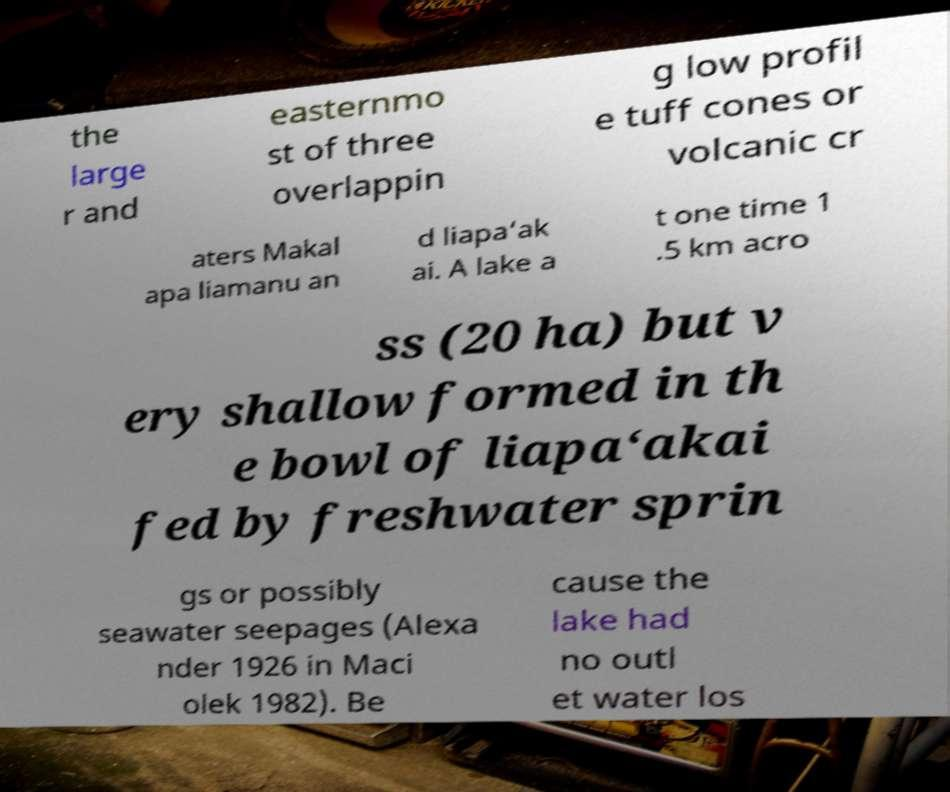I need the written content from this picture converted into text. Can you do that? the large r and easternmo st of three overlappin g low profil e tuff cones or volcanic cr aters Makal apa liamanu an d liapa‘ak ai. A lake a t one time 1 .5 km acro ss (20 ha) but v ery shallow formed in th e bowl of liapa‘akai fed by freshwater sprin gs or possibly seawater seepages (Alexa nder 1926 in Maci olek 1982). Be cause the lake had no outl et water los 